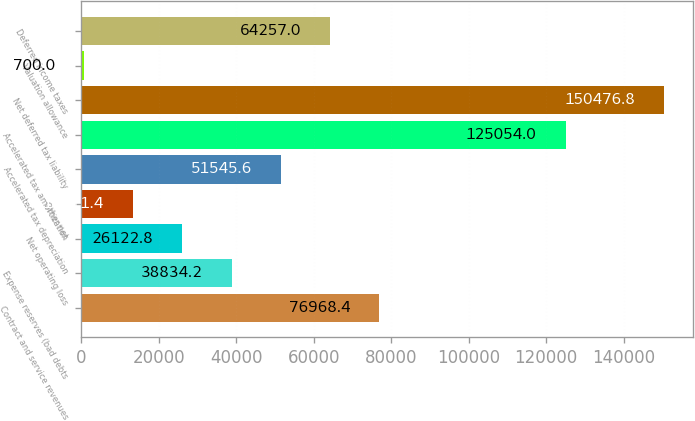Convert chart to OTSL. <chart><loc_0><loc_0><loc_500><loc_500><bar_chart><fcel>Contract and service revenues<fcel>Expense reserves (bad debts<fcel>Net operating loss<fcel>Other net<fcel>Accelerated tax depreciation<fcel>Accelerated tax amortization<fcel>Net deferred tax liability<fcel>Valuation allowance<fcel>Deferred income taxes<nl><fcel>76968.4<fcel>38834.2<fcel>26122.8<fcel>13411.4<fcel>51545.6<fcel>125054<fcel>150477<fcel>700<fcel>64257<nl></chart> 